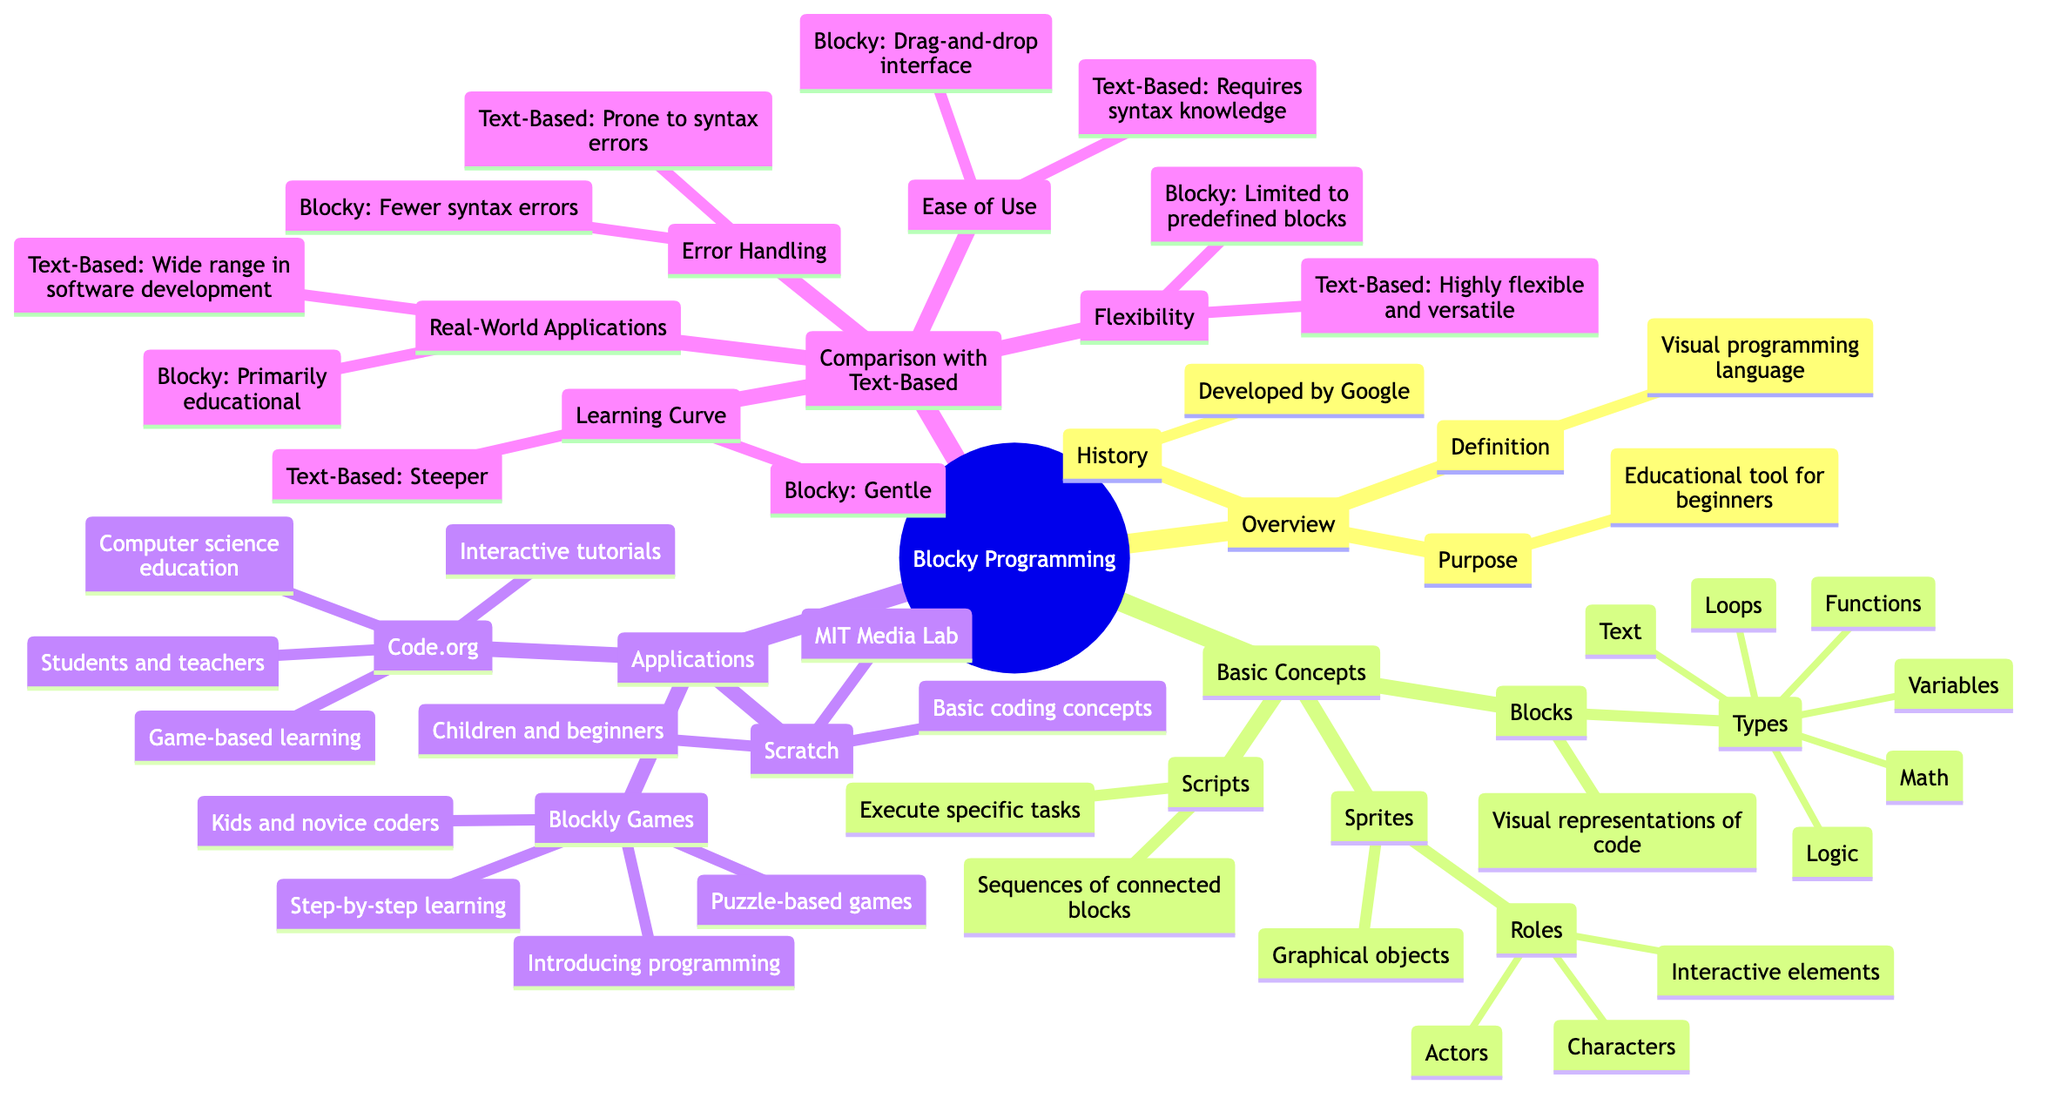What is the purpose of Blocky? The purpose node under the Overview section clearly states that Blocky is designed as an educational tool for beginners.
Answer: Educational tool for beginners How many types of blocks are defined in Blocky? The Basic Concepts section lists several types of blocks, specifically under the Blocks node, where it mentions six different types.
Answer: 6 What does a script in Blocky define? In the Basic Concepts section, the Scripts node states that a script is a sequence of connected blocks defined to execute a specific task.
Answer: Sequences of connected blocks Who created Scratch? The Applications in Educational Tools section identifies MIT Media Lab as the creator of Scratch.
Answer: MIT Media Lab Which application targets both students and teachers? Within the Applications section, Code.org is mentioned to target Students and Teachers, thus answering the question.
Answer: Code.org What is a distinguishing feature of Blocky compared to text-based languages in error handling? The Comparison with Traditional Text-Based Programming Languages section states that Blocky has fewer syntax errors while text-based programming is prone to such errors.
Answer: Fewer syntax errors What role do sprites play in Blocky? In the Basic Concepts section, the Sprites node lists that sprites serve as graphical objects with specified roles such as characters and interactive elements.
Answer: Characters, Actors, Interactive elements How does Blocky differ from text-based programming in its learning curve? The Comparison section indicates that Blocky has a gentle learning curve, whereas text-based programming features a steeper learning curve, highlighting the difference in complexity.
Answer: Gentle learning curve What focuses does Blockly Games promote? The Applications in Educational Tools section identifies the focus of Blockly Games as introducing programming to kids and novice coders through puzzle-based games.
Answer: Introducing programming 